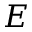Convert formula to latex. <formula><loc_0><loc_0><loc_500><loc_500>E</formula> 